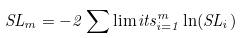<formula> <loc_0><loc_0><loc_500><loc_500>S L _ { m } = - 2 \sum \lim i t s _ { i = 1 } ^ { m } \ln ( S L _ { i } )</formula> 